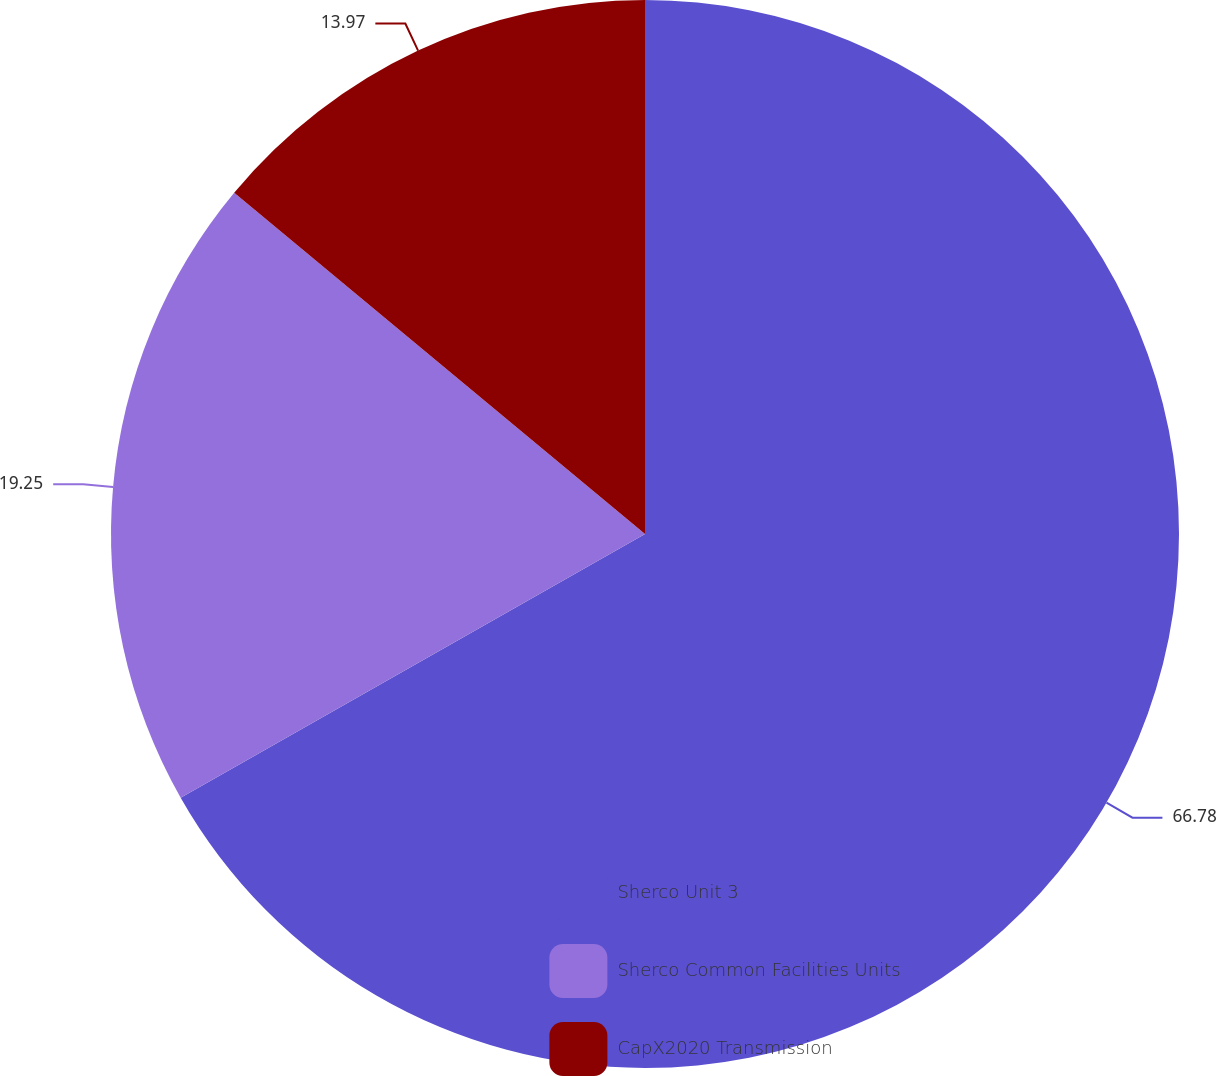Convert chart to OTSL. <chart><loc_0><loc_0><loc_500><loc_500><pie_chart><fcel>Sherco Unit 3<fcel>Sherco Common Facilities Units<fcel>CapX2020 Transmission<nl><fcel>66.78%<fcel>19.25%<fcel>13.97%<nl></chart> 